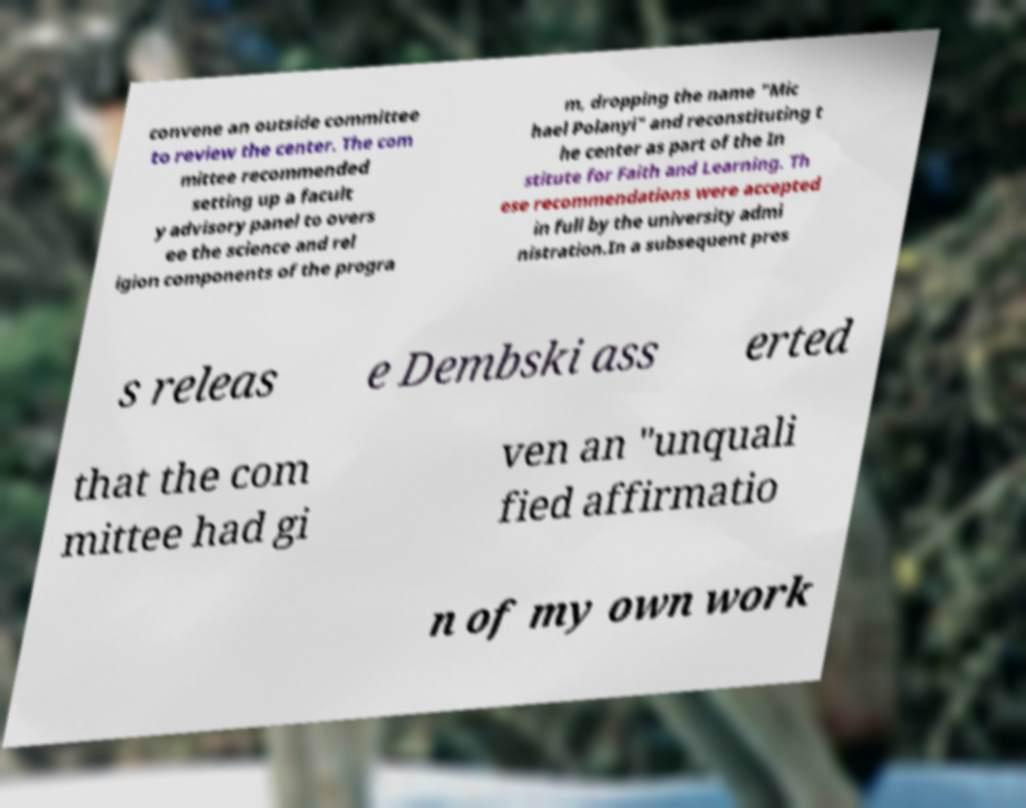I need the written content from this picture converted into text. Can you do that? convene an outside committee to review the center. The com mittee recommended setting up a facult y advisory panel to overs ee the science and rel igion components of the progra m, dropping the name "Mic hael Polanyi" and reconstituting t he center as part of the In stitute for Faith and Learning. Th ese recommendations were accepted in full by the university admi nistration.In a subsequent pres s releas e Dembski ass erted that the com mittee had gi ven an "unquali fied affirmatio n of my own work 